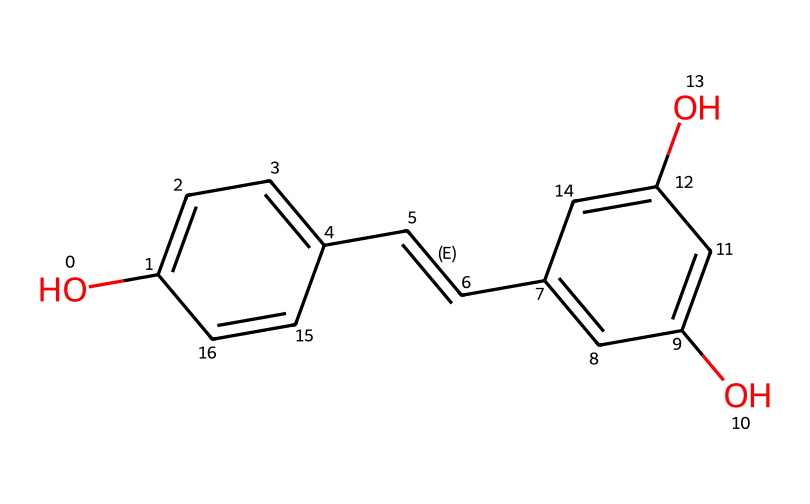What is the name of this chemical? The chemical structure corresponds to the SMILES notation provided, which identifies it as resveratrol.
Answer: resveratrol How many hydroxyl (OH) groups are present? By examining the structure, there are three hydroxyl (OH) groups indicated by their presence on the aromatic rings.
Answer: three What is the degree of unsaturation in this molecule? The degree of unsaturation can be calculated by assessing the rings and double bonds in the structure; there are three rings and one double bond present.
Answer: four What type of chemical compound is resveratrol? Resveratrol is primarily classified as a polyphenol due to its multiple phenolic structures.
Answer: polyphenol Does this compound contribute to antioxidant activity? Yes, the presence of hydroxyl groups in the structure allows it to donate electrons, acting as an effective antioxidant.
Answer: yes Which part of the molecule is responsible for its antioxidant properties? The hydroxyl groups provide the ability to neutralize free radicals, which is crucial for its antioxidant activity.
Answer: hydroxyl groups 